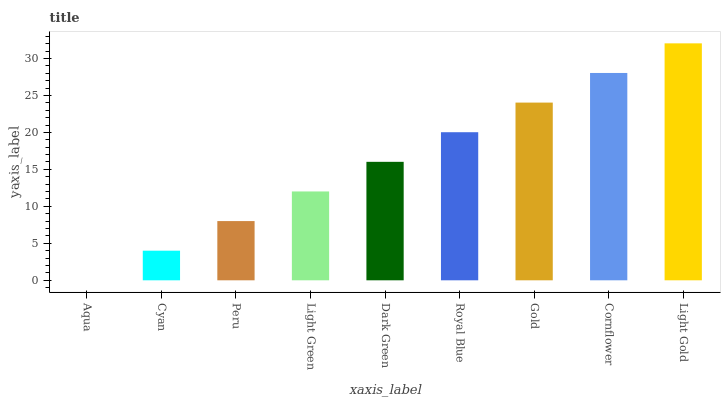Is Cyan the minimum?
Answer yes or no. No. Is Cyan the maximum?
Answer yes or no. No. Is Cyan greater than Aqua?
Answer yes or no. Yes. Is Aqua less than Cyan?
Answer yes or no. Yes. Is Aqua greater than Cyan?
Answer yes or no. No. Is Cyan less than Aqua?
Answer yes or no. No. Is Dark Green the high median?
Answer yes or no. Yes. Is Dark Green the low median?
Answer yes or no. Yes. Is Cornflower the high median?
Answer yes or no. No. Is Gold the low median?
Answer yes or no. No. 